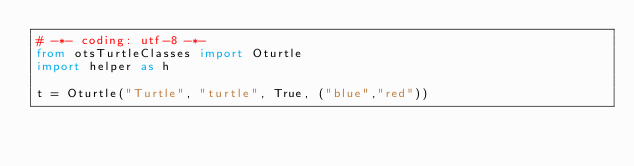Convert code to text. <code><loc_0><loc_0><loc_500><loc_500><_Python_># -*- coding: utf-8 -*-
from otsTurtleClasses import Oturtle
import helper as h

t = Oturtle("Turtle", "turtle", True, ("blue","red"))</code> 